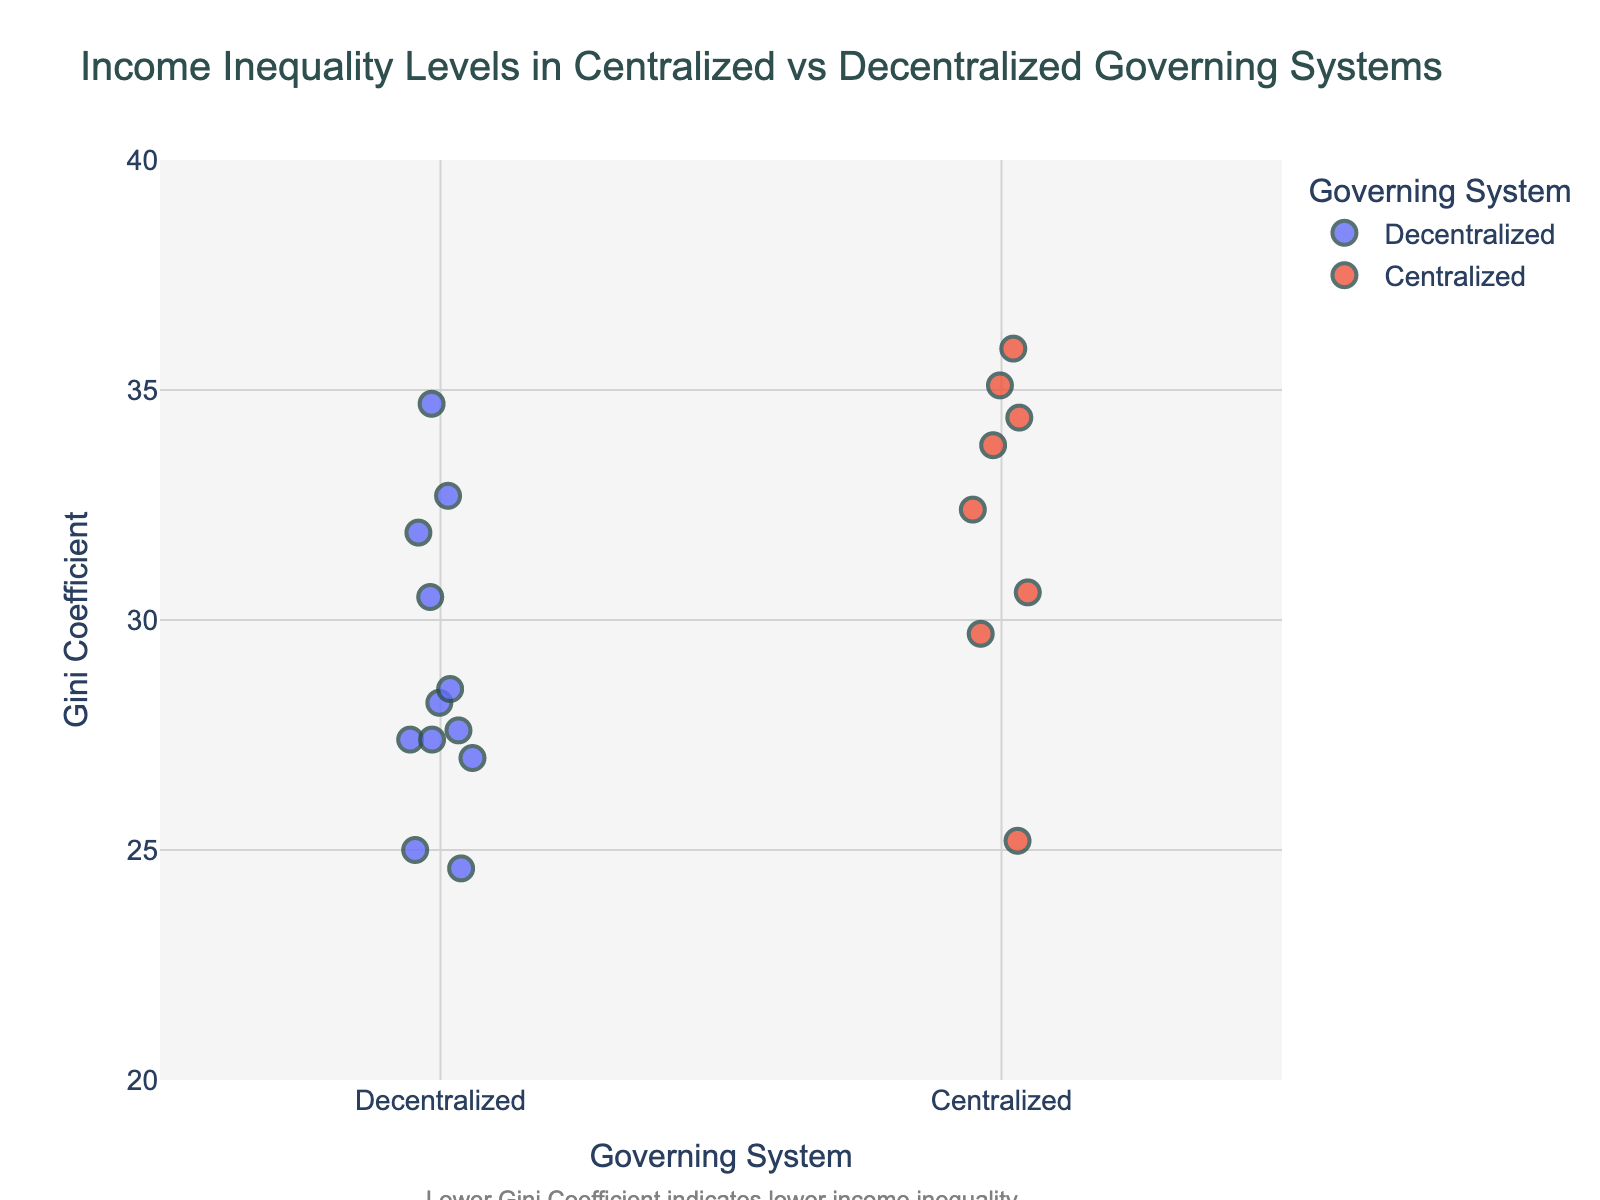what is the title of the figure? The title is prominently displayed at the top of the figure, summarizing its content.
Answer: "Income Inequality Levels in Centralized vs Decentralized Governing Systems" How many data points are in the plot total? We need to count the number of individual points marked on the plot.
Answer: 20 What is the Gini Coefficient range for decentralized systems in the plot? Look at the y-axis for the range covered by points with the "Decentralized" label.
Answer: 24.6 to 34.7 Which country has the highest Gini Coefficient among decentralized systems? Identify the point with the highest y-value in the "Decentralized" category and check its hover information for the country name.
Answer: Spain Which system has a lower median Gini Coefficient: centralized or decentralized? Find the middle value of the Gini Coefficient for each system and compare them.
Answer: Decentralized How many countries in the centralized system have a Gini Coefficient greater than 34? Count the number of points above the y-value of 34 in the "Centralized" category.
Answer: 3 Which centralized country has the lowest Gini Coefficient? Identify the point with the lowest y-value in the "Centralized" category and check its hover information for the country name.
Answer: Slovakia What is the difference between the highest and lowest Gini Coefficients in decentralized systems? Subtract the lowest Gini Coefficient from the highest in the "Decentralized" category (34.7 - 24.6).
Answer: 10.1 Are there more countries with Gini Coefficients below 30 in centralized or decentralized systems? Count the number of points below the y-value of 30 in each category and compare.
Answer: Decentralized What is the average Gini Coefficient for centralized systems? Add all the Gini Coefficient values for centralized systems and divide by the number of centralized data points for the mean value.
Answer: About 32.5 